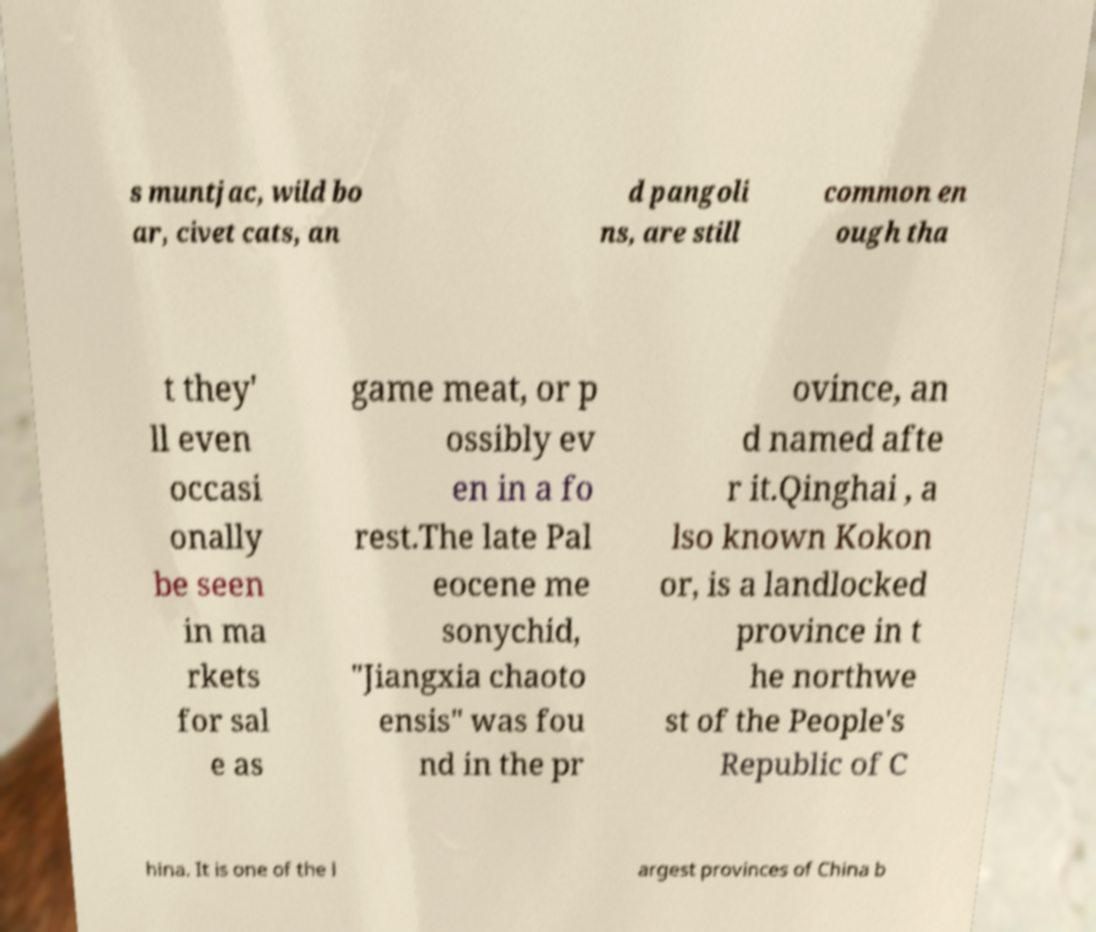Please read and relay the text visible in this image. What does it say? s muntjac, wild bo ar, civet cats, an d pangoli ns, are still common en ough tha t they' ll even occasi onally be seen in ma rkets for sal e as game meat, or p ossibly ev en in a fo rest.The late Pal eocene me sonychid, "Jiangxia chaoto ensis" was fou nd in the pr ovince, an d named afte r it.Qinghai , a lso known Kokon or, is a landlocked province in t he northwe st of the People's Republic of C hina. It is one of the l argest provinces of China b 